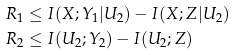Convert formula to latex. <formula><loc_0><loc_0><loc_500><loc_500>R _ { 1 } & \leq I ( X ; Y _ { 1 } | U _ { 2 } ) - I ( X ; Z | U _ { 2 } ) \\ R _ { 2 } & \leq I ( U _ { 2 } ; Y _ { 2 } ) - I ( U _ { 2 } ; Z )</formula> 